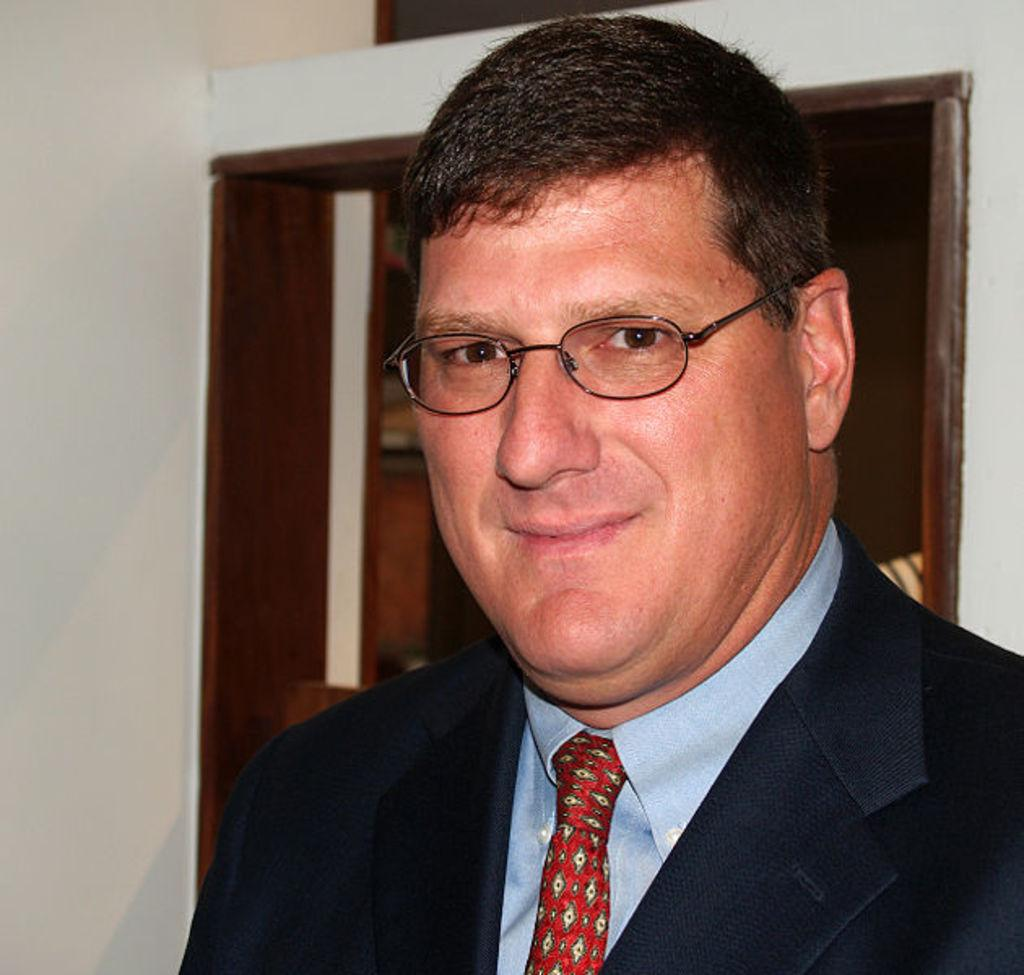What is the main subject of the image? The main subject of the image is a man. Can you describe the man's attire in the image? The man is wearing a tie, a shirt, and a coat in the image. What accessory is the man wearing in the image? The man is wearing spectacles in the image. Can you tell me how many horns are visible on the man's head in the image? There are no horns visible on the man's head in the image. What type of humor is the man telling in the image? There is no indication of humor or any joke being told in the image. 